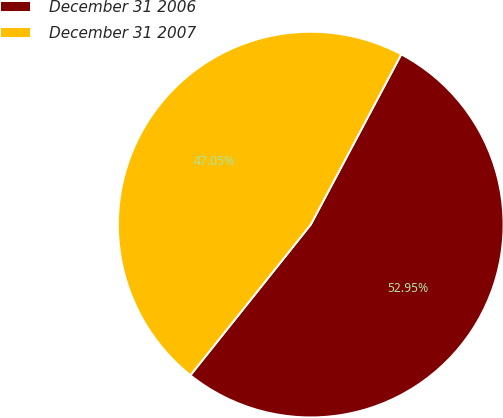<chart> <loc_0><loc_0><loc_500><loc_500><pie_chart><fcel>December 31 2006<fcel>December 31 2007<nl><fcel>52.95%<fcel>47.05%<nl></chart> 